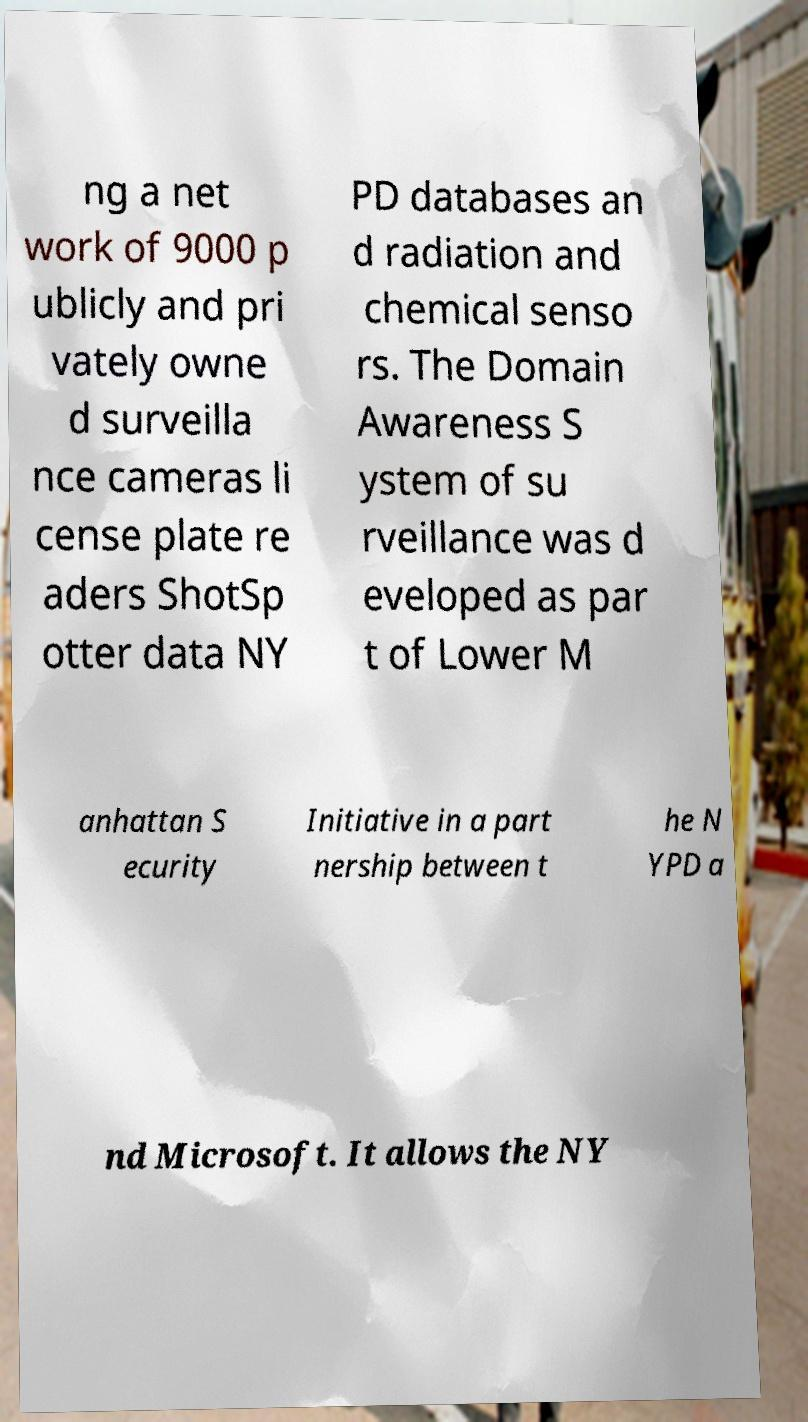There's text embedded in this image that I need extracted. Can you transcribe it verbatim? ng a net work of 9000 p ublicly and pri vately owne d surveilla nce cameras li cense plate re aders ShotSp otter data NY PD databases an d radiation and chemical senso rs. The Domain Awareness S ystem of su rveillance was d eveloped as par t of Lower M anhattan S ecurity Initiative in a part nership between t he N YPD a nd Microsoft. It allows the NY 